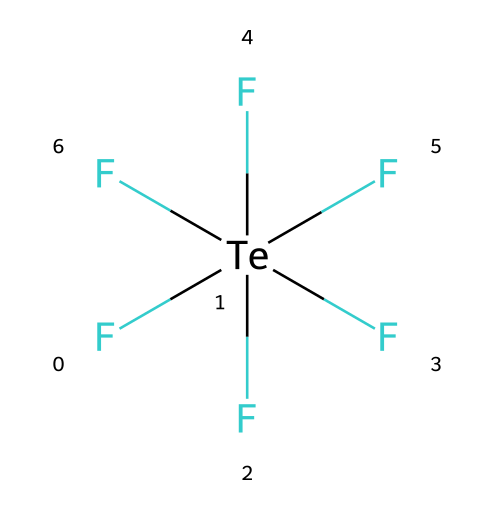What is the total number of fluorine atoms in this molecule? The SMILES representation shows six "F" characters, indicating that there are a total of six fluorine atoms directly bonded to the central tellurium atom.
Answer: six What is the central atom in this compound? The central atom is identified as "Te" in the SMILES notation, which represents tellurium.
Answer: tellurium How many single bonds are present between tellurium and fluorine? Each "F" in the SMILES denotation is connected to the tellurium atom with a single bond, resulting in a count of six single bonds between tellurium and the six fluorine atoms.
Answer: six Is tellurium hexafluoride polar or nonpolar? The presence of six highly electronegative fluorine atoms surrounding the tellurium atom creates a symmetrical shape, which renders the overall molecule nonpolar despite the individual bonds being polar.
Answer: nonpolar What hybridization state is tellurium in for tellurium hexafluoride? In this compound, tellurium is surrounded by six bonding pairs of electrons, indicating it has an sp^3d^2 hybridization state accommodating the six fluorine atoms in an octahedral geometry.
Answer: sp3d2 What is the molecular geometry of tellurium hexafluoride? Given the six fluorine atoms bonded to the tellurium atom in an equatorial and axial arrangement, this results in an octahedral molecular geometry.
Answer: octahedral What type of molecule is tellurium hexafluoride classified as? This molecule is classified as a hypervalent compound due to the presence of more than four bonds surrounding the tellurium atom.
Answer: hypervalent 